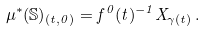<formula> <loc_0><loc_0><loc_500><loc_500>\mu ^ { * } ( { \mathbb { S } } ) _ { ( t , 0 ) } = f ^ { 0 } ( t ) ^ { - 1 } X _ { \gamma ( t ) } \, .</formula> 